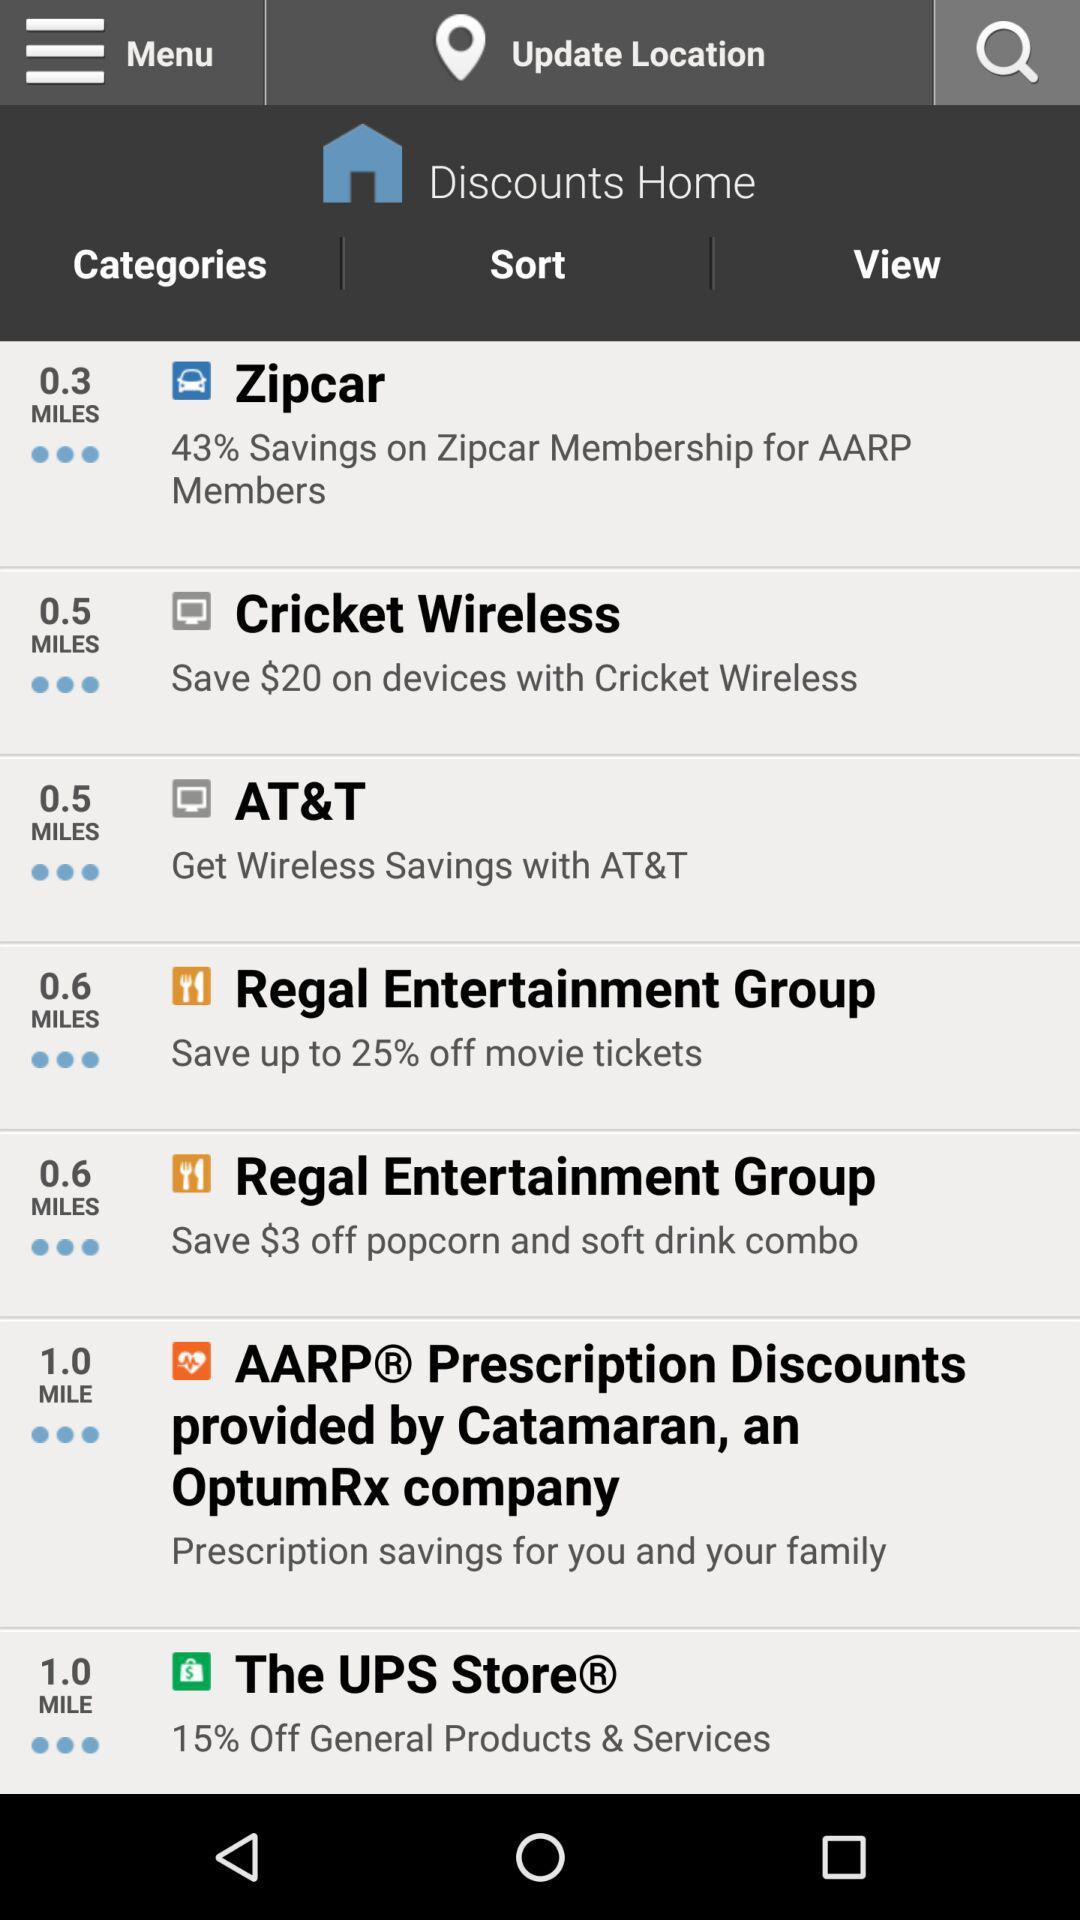How much discount is available on general products and services at "The UPS Store"? The available discount is 15%. 